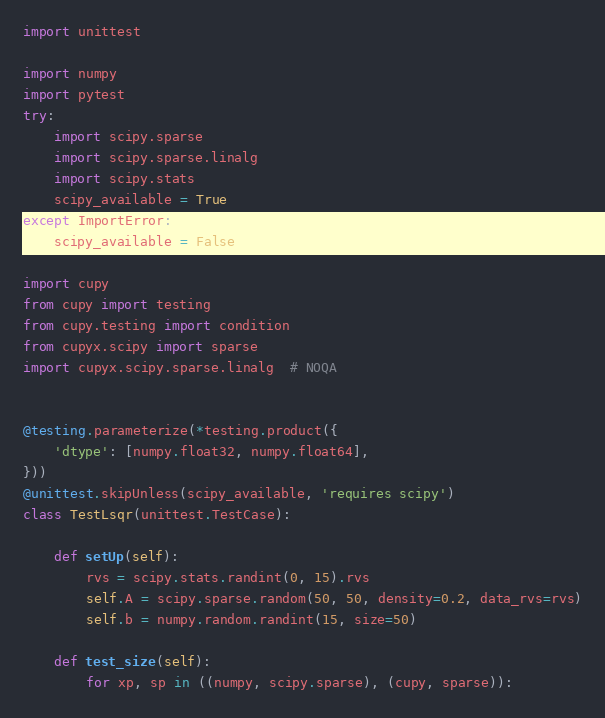Convert code to text. <code><loc_0><loc_0><loc_500><loc_500><_Python_>import unittest

import numpy
import pytest
try:
    import scipy.sparse
    import scipy.sparse.linalg
    import scipy.stats
    scipy_available = True
except ImportError:
    scipy_available = False

import cupy
from cupy import testing
from cupy.testing import condition
from cupyx.scipy import sparse
import cupyx.scipy.sparse.linalg  # NOQA


@testing.parameterize(*testing.product({
    'dtype': [numpy.float32, numpy.float64],
}))
@unittest.skipUnless(scipy_available, 'requires scipy')
class TestLsqr(unittest.TestCase):

    def setUp(self):
        rvs = scipy.stats.randint(0, 15).rvs
        self.A = scipy.sparse.random(50, 50, density=0.2, data_rvs=rvs)
        self.b = numpy.random.randint(15, size=50)

    def test_size(self):
        for xp, sp in ((numpy, scipy.sparse), (cupy, sparse)):</code> 